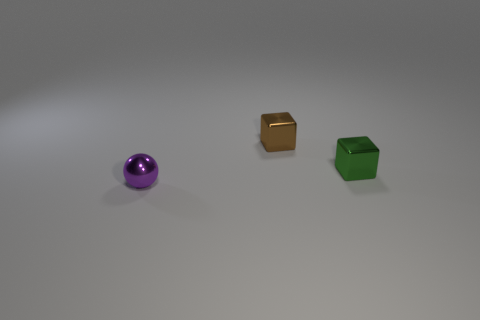What number of brown objects are shiny blocks or metal spheres?
Ensure brevity in your answer.  1. How many other brown objects are the same shape as the tiny brown object?
Your answer should be compact. 0. What number of other brown balls are the same size as the sphere?
Provide a succinct answer. 0. What is the color of the block that is left of the tiny green thing?
Make the answer very short. Brown. Is the number of tiny green shiny cubes that are behind the tiny purple object greater than the number of small cyan shiny cylinders?
Give a very brief answer. Yes. What color is the tiny sphere?
Your response must be concise. Purple. There is a metal object that is to the right of the object that is behind the metallic object to the right of the brown metal object; what shape is it?
Keep it short and to the point. Cube. The small thing right of the metal block left of the tiny green cube is what shape?
Provide a succinct answer. Cube. Do the brown metallic thing and the metal thing that is in front of the tiny green metal cube have the same size?
Your answer should be compact. Yes. What number of large objects are cyan metal things or brown things?
Keep it short and to the point. 0. 